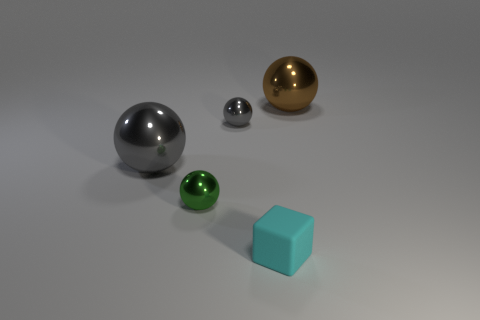Subtract all brown cylinders. How many gray balls are left? 2 Subtract all yellow balls. Subtract all purple blocks. How many balls are left? 4 Add 1 big cyan cubes. How many objects exist? 6 Subtract all blue shiny cubes. Subtract all small gray shiny objects. How many objects are left? 4 Add 5 cubes. How many cubes are left? 6 Add 1 tiny matte things. How many tiny matte things exist? 2 Subtract 1 green balls. How many objects are left? 4 Subtract all blocks. How many objects are left? 4 